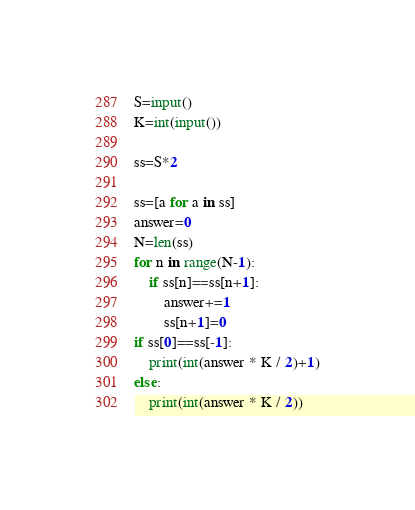<code> <loc_0><loc_0><loc_500><loc_500><_Python_>S=input()
K=int(input())

ss=S*2

ss=[a for a in ss]
answer=0
N=len(ss)
for n in range(N-1):
    if ss[n]==ss[n+1]:
        answer+=1
        ss[n+1]=0
if ss[0]==ss[-1]:
    print(int(answer * K / 2)+1)
else:
    print(int(answer * K / 2))

</code> 